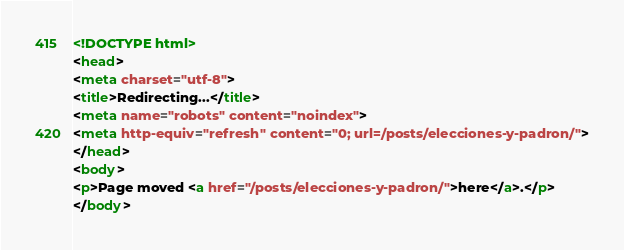<code> <loc_0><loc_0><loc_500><loc_500><_HTML_><!DOCTYPE html>
<head>
<meta charset="utf-8">
<title>Redirecting...</title>
<meta name="robots" content="noindex">
<meta http-equiv="refresh" content="0; url=/posts/elecciones-y-padron/">
</head>
<body>
<p>Page moved <a href="/posts/elecciones-y-padron/">here</a>.</p>
</body></code> 